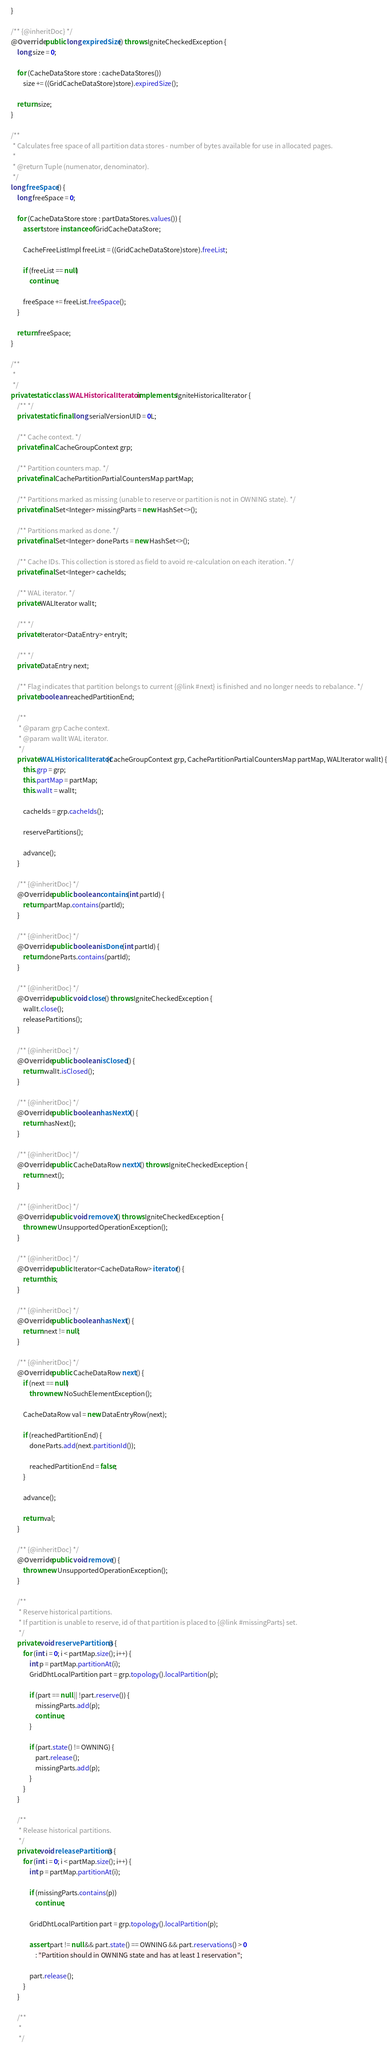<code> <loc_0><loc_0><loc_500><loc_500><_Java_>    }

    /** {@inheritDoc} */
    @Override public long expiredSize() throws IgniteCheckedException {
        long size = 0;

        for (CacheDataStore store : cacheDataStores())
            size += ((GridCacheDataStore)store).expiredSize();

        return size;
    }

    /**
     * Calculates free space of all partition data stores - number of bytes available for use in allocated pages.
     *
     * @return Tuple (numenator, denominator).
     */
    long freeSpace() {
        long freeSpace = 0;

        for (CacheDataStore store : partDataStores.values()) {
            assert store instanceof GridCacheDataStore;

            CacheFreeListImpl freeList = ((GridCacheDataStore)store).freeList;

            if (freeList == null)
                continue;

            freeSpace += freeList.freeSpace();
        }

        return freeSpace;
    }

    /**
     *
     */
    private static class WALHistoricalIterator implements IgniteHistoricalIterator {
        /** */
        private static final long serialVersionUID = 0L;

        /** Cache context. */
        private final CacheGroupContext grp;

        /** Partition counters map. */
        private final CachePartitionPartialCountersMap partMap;

        /** Partitions marked as missing (unable to reserve or partition is not in OWNING state). */
        private final Set<Integer> missingParts = new HashSet<>();

        /** Partitions marked as done. */
        private final Set<Integer> doneParts = new HashSet<>();

        /** Cache IDs. This collection is stored as field to avoid re-calculation on each iteration. */
        private final Set<Integer> cacheIds;

        /** WAL iterator. */
        private WALIterator walIt;

        /** */
        private Iterator<DataEntry> entryIt;

        /** */
        private DataEntry next;

        /** Flag indicates that partition belongs to current {@link #next} is finished and no longer needs to rebalance. */
        private boolean reachedPartitionEnd;

        /**
         * @param grp Cache context.
         * @param walIt WAL iterator.
         */
        private WALHistoricalIterator(CacheGroupContext grp, CachePartitionPartialCountersMap partMap, WALIterator walIt) {
            this.grp = grp;
            this.partMap = partMap;
            this.walIt = walIt;

            cacheIds = grp.cacheIds();

            reservePartitions();

            advance();
        }

        /** {@inheritDoc} */
        @Override public boolean contains(int partId) {
            return partMap.contains(partId);
        }

        /** {@inheritDoc} */
        @Override public boolean isDone(int partId) {
            return doneParts.contains(partId);
        }

        /** {@inheritDoc} */
        @Override public void close() throws IgniteCheckedException {
            walIt.close();
            releasePartitions();
        }

        /** {@inheritDoc} */
        @Override public boolean isClosed() {
            return walIt.isClosed();
        }

        /** {@inheritDoc} */
        @Override public boolean hasNextX() {
            return hasNext();
        }

        /** {@inheritDoc} */
        @Override public CacheDataRow nextX() throws IgniteCheckedException {
            return next();
        }

        /** {@inheritDoc} */
        @Override public void removeX() throws IgniteCheckedException {
            throw new UnsupportedOperationException();
        }

        /** {@inheritDoc} */
        @Override public Iterator<CacheDataRow> iterator() {
            return this;
        }

        /** {@inheritDoc} */
        @Override public boolean hasNext() {
            return next != null;
        }

        /** {@inheritDoc} */
        @Override public CacheDataRow next() {
            if (next == null)
                throw new NoSuchElementException();

            CacheDataRow val = new DataEntryRow(next);

            if (reachedPartitionEnd) {
                doneParts.add(next.partitionId());

                reachedPartitionEnd = false;
            }

            advance();

            return val;
        }

        /** {@inheritDoc} */
        @Override public void remove() {
            throw new UnsupportedOperationException();
        }

        /**
         * Reserve historical partitions.
         * If partition is unable to reserve, id of that partition is placed to {@link #missingParts} set.
         */
        private void reservePartitions() {
            for (int i = 0; i < partMap.size(); i++) {
                int p = partMap.partitionAt(i);
                GridDhtLocalPartition part = grp.topology().localPartition(p);

                if (part == null || !part.reserve()) {
                    missingParts.add(p);
                    continue;
                }

                if (part.state() != OWNING) {
                    part.release();
                    missingParts.add(p);
                }
            }
        }

        /**
         * Release historical partitions.
         */
        private void releasePartitions() {
            for (int i = 0; i < partMap.size(); i++) {
                int p = partMap.partitionAt(i);

                if (missingParts.contains(p))
                    continue;

                GridDhtLocalPartition part = grp.topology().localPartition(p);

                assert part != null && part.state() == OWNING && part.reservations() > 0
                    : "Partition should in OWNING state and has at least 1 reservation";

                part.release();
            }
        }

        /**
         *
         */</code> 